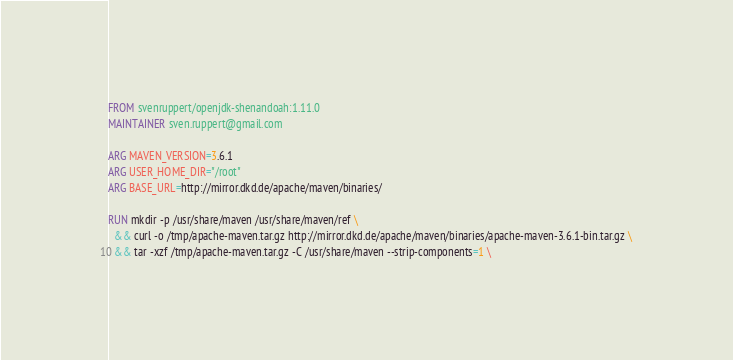Convert code to text. <code><loc_0><loc_0><loc_500><loc_500><_Dockerfile_>FROM svenruppert/openjdk-shenandoah:1.11.0
MAINTAINER sven.ruppert@gmail.com

ARG MAVEN_VERSION=3.6.1
ARG USER_HOME_DIR="/root"
ARG BASE_URL=http://mirror.dkd.de/apache/maven/binaries/

RUN mkdir -p /usr/share/maven /usr/share/maven/ref \
  && curl -o /tmp/apache-maven.tar.gz http://mirror.dkd.de/apache/maven/binaries/apache-maven-3.6.1-bin.tar.gz \
  && tar -xzf /tmp/apache-maven.tar.gz -C /usr/share/maven --strip-components=1 \</code> 